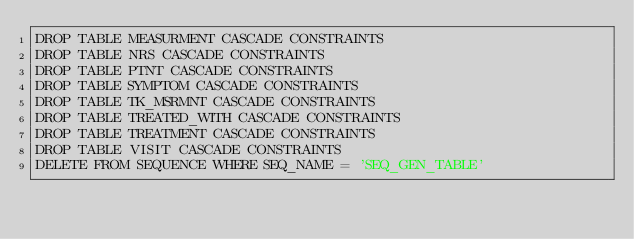Convert code to text. <code><loc_0><loc_0><loc_500><loc_500><_SQL_>DROP TABLE MEASURMENT CASCADE CONSTRAINTS
DROP TABLE NRS CASCADE CONSTRAINTS
DROP TABLE PTNT CASCADE CONSTRAINTS
DROP TABLE SYMPTOM CASCADE CONSTRAINTS
DROP TABLE TK_MSRMNT CASCADE CONSTRAINTS
DROP TABLE TREATED_WITH CASCADE CONSTRAINTS
DROP TABLE TREATMENT CASCADE CONSTRAINTS
DROP TABLE VISIT CASCADE CONSTRAINTS
DELETE FROM SEQUENCE WHERE SEQ_NAME = 'SEQ_GEN_TABLE'
</code> 